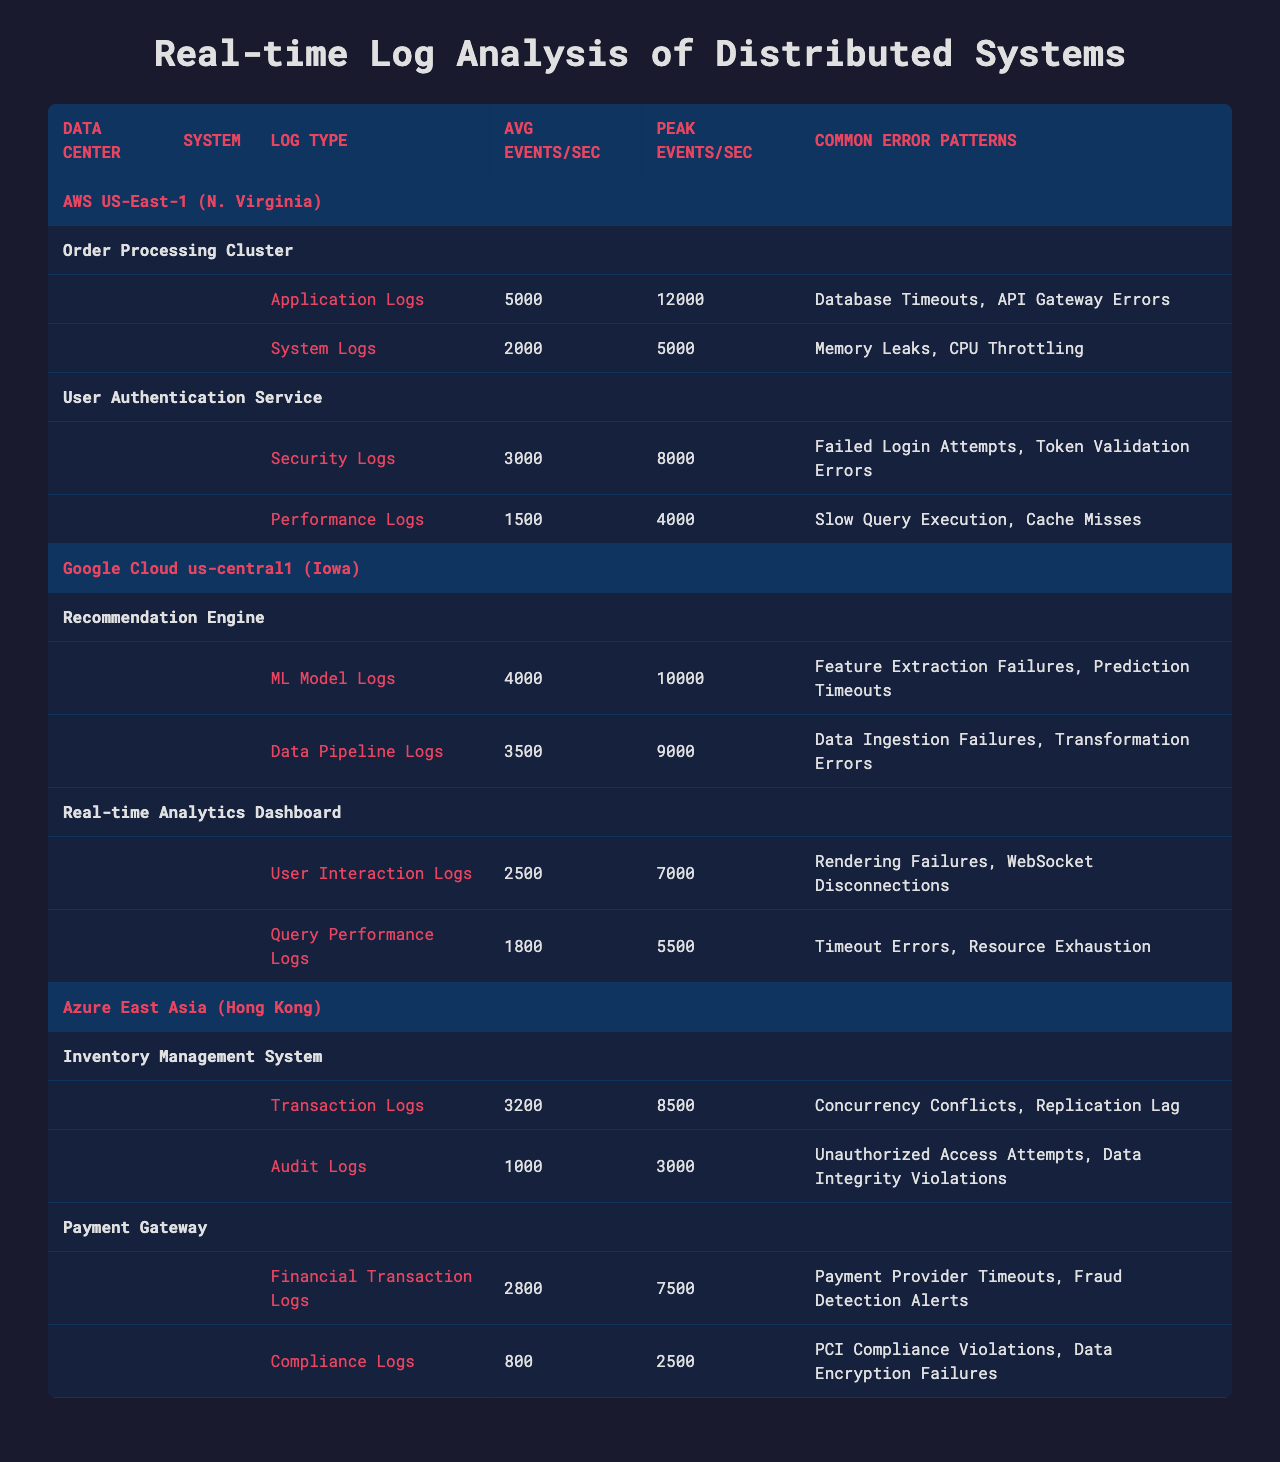What is the average events per second for the "Order Processing Cluster"? From the table, the "Order Processing Cluster" has an average of 5000 events per second for Application Logs and 2000 for System Logs. The average is therefore 5000 + 2000 = 7000 events per second total.
Answer: 7000 Which data center has the highest peak events per second? The peak events per second for each data center is as follows: AWS US-East-1: 12000, Google Cloud us-central1: 10000, Azure East Asia: 8500. The highest peak is 12000 events per second in AWS US-East-1.
Answer: AWS US-East-1 How many common error patterns exist for the "Payment Gateway"? The "Payment Gateway" has two log types: "Financial Transaction Logs" and "Compliance Logs", both of which list two common error patterns. Therefore, there are a total of 4 common error patterns.
Answer: 4 Does the "Recommendation Engine" generate more average events than the "User Authentication Service"? The "Recommendation Engine" generates 4000 (ML Model Logs) + 3500 (Data Pipeline Logs) = 7500 average events per second, while the "User Authentication Service" generates 3000 (Security Logs) + 1500 (Performance Logs) = 4500 average events per second. Therefore, the "Recommendation Engine" does generate more average events.
Answer: Yes What is the total average events per second for systems in Azure East Asia? The "Inventory Management System" has an average of 3200 (Transaction Logs) + 1000 (Audit Logs) = 4200 events per second, and the "Payment Gateway" has an average of 2800 (Financial Transaction Logs) + 800 (Compliance Logs) = 3600 events per second. Summing these gives 4200 + 3600 = 7800 total average events per second for Azure East Asia.
Answer: 7800 Which system has the lowest average events per second among the three data centers? The "Compliance Logs" from the "Payment Gateway" in Azure East Asia has an average of 800 events per second, which is lower than all other average events recorded in the systems.
Answer: Compliance Logs (Payment Gateway) What are the common error patterns for "Application Logs" in AWS US-East-1? The "Application Logs" in AWS US-East-1 list "Database Timeouts" and "API Gateway Errors" as common error patterns.
Answer: Database Timeouts, API Gateway Errors Are there any systems in Google Cloud us-central1 that generate more than 3000 average events per second? Yes, both the "Recommendation Engine" (7500) and the "Real-time Analytics Dashboard" (4300) generate more than 3000 average events per second when their logs are summed.
Answer: Yes What is the difference in peak events per second between "Inventory Management System" and "Payment Gateway" in Azure East Asia? The "Inventory Management System" has a peak of 8500 events per second and the "Payment Gateway" has a peak of 7500 events per second. The difference is 8500 - 7500 = 1000 events per second.
Answer: 1000 Which log type has the highest average events per second across all data centers? The highest average events per second is from the "Order Processing Cluster" Application Logs at 5000 events per second, which is higher than any other log type listed.
Answer: Application Logs (Order Processing Cluster) 